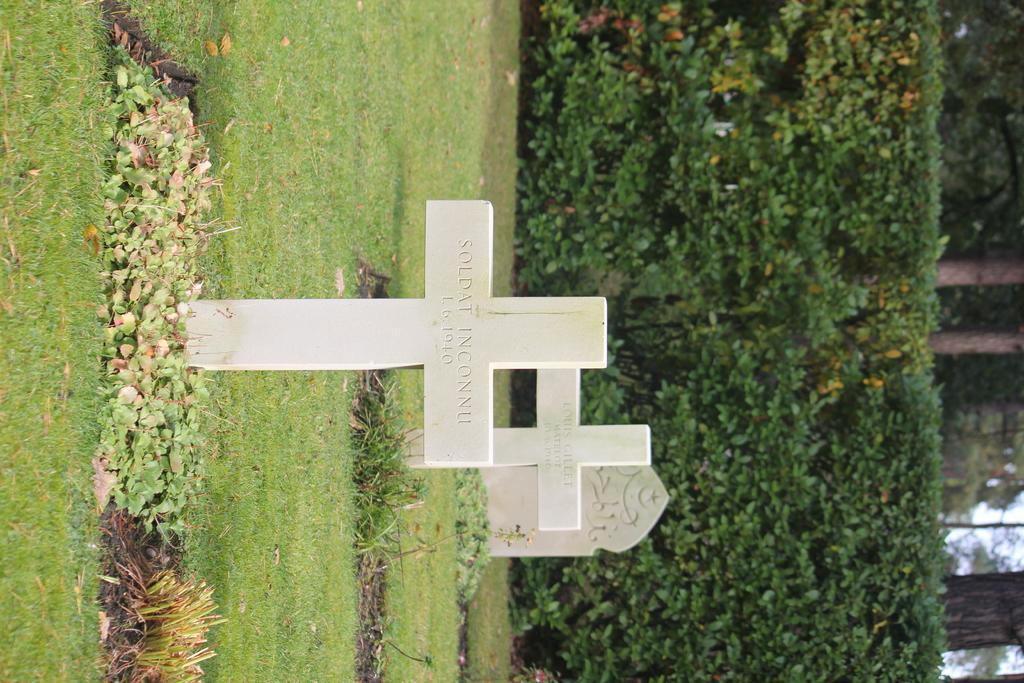What symbols can be seen in the image? There are two cross symbols in white color in the image. What type of location is depicted in the image? There is a cemetery in the image. What type of vegetation is present in the image? There are green trees in the image. What is the ground covered with in the image? There is grass in the image. How many ducks are sleeping on the grass in the image? There are no ducks present in the image; it features a cemetery with green trees and grass. What type of collar is visible on the trees in the image? There are no collars present on the trees in the image; they are simply green trees. 